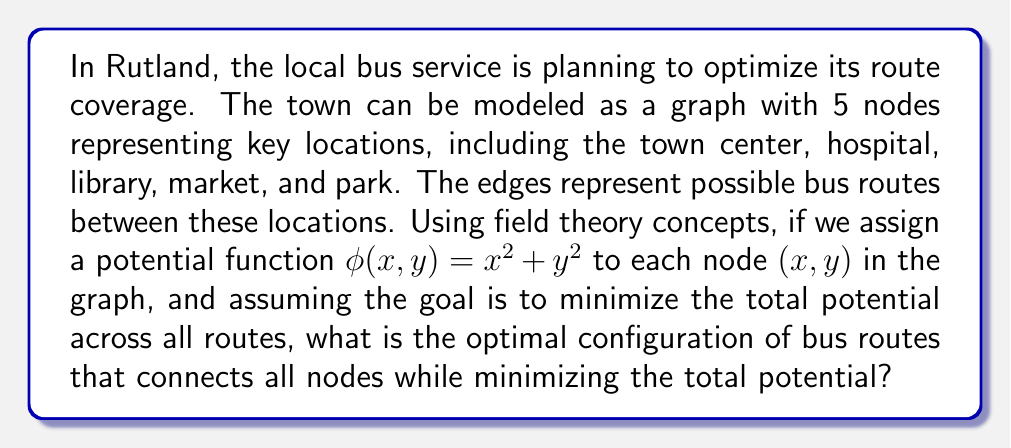What is the answer to this math problem? Let's approach this step-by-step:

1) First, we need to assign coordinates to our nodes. Let's use the following:
   Town Center (0,0), Hospital (1,2), Library (-1,1), Market (2,1), Park (-2,-1)

2) Now, we calculate the potential for each node using $\phi(x,y) = x^2 + y^2$:
   Town Center: $\phi(0,0) = 0$
   Hospital: $\phi(1,2) = 1^2 + 2^2 = 5$
   Library: $\phi(-1,1) = (-1)^2 + 1^2 = 2$
   Market: $\phi(2,1) = 2^2 + 1^2 = 5$
   Park: $\phi(-2,-1) = (-2)^2 + (-1)^2 = 5$

3) In graph theory, the minimal spanning tree (MST) connects all nodes with the minimum total edge weight. Here, our edge weights will be the sum of potentials of the nodes they connect.

4) To find the MST, we can use Kruskal's algorithm:
   a) Sort all edges by weight (sum of node potentials)
   b) Start with an empty graph
   c) Add edges in order of increasing weight, skipping those that would create a cycle

5) Calculating edge weights:
   Town Center - Hospital: 0 + 5 = 5
   Town Center - Library: 0 + 2 = 2
   Town Center - Market: 0 + 5 = 5
   Town Center - Park: 0 + 5 = 5
   Hospital - Library: 5 + 2 = 7
   Hospital - Market: 5 + 5 = 10
   Hospital - Park: 5 + 5 = 10
   Library - Market: 2 + 5 = 7
   Library - Park: 2 + 5 = 7
   Market - Park: 5 + 5 = 10

6) Sorting edges: 
   Town Center - Library (2)
   Town Center - Hospital (5)
   Town Center - Market (5)
   Town Center - Park (5)
   Library - Market (7)
   Library - Park (7)

7) Applying Kruskal's algorithm:
   a) Add Town Center - Library
   b) Add Town Center - Hospital
   c) Add Town Center - Market
   d) Add Town Center - Park

This connects all nodes with the minimum total potential.
Answer: The optimal bus route configuration is a star topology with the Town Center as the hub, directly connected to the Hospital, Library, Market, and Park. 